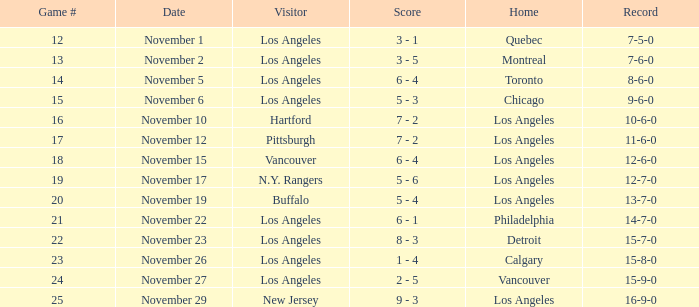What is the number of points of the game less than number 17 with an 11-6-0 record? None. 